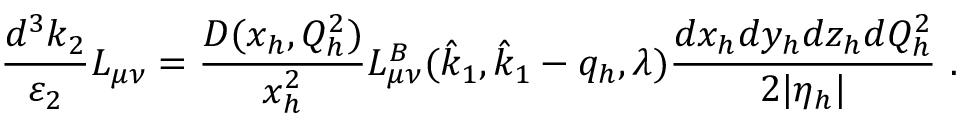<formula> <loc_0><loc_0><loc_500><loc_500>\frac { d ^ { 3 } k _ { 2 } } { \varepsilon _ { 2 } } L _ { \mu \nu } = \frac { D ( x _ { h } , Q _ { h } ^ { 2 } ) } { x _ { h } ^ { 2 } } L _ { \mu \nu } ^ { B } ( \hat { k } _ { 1 } , \hat { k } _ { 1 } - q _ { h } , \lambda ) \frac { d x _ { h } d y _ { h } d z _ { h } d Q _ { h } ^ { 2 } } { 2 | \eta _ { h } | } \ .</formula> 